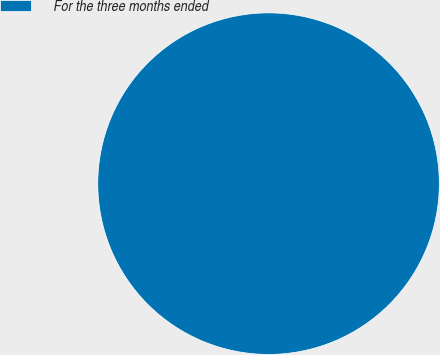Convert chart. <chart><loc_0><loc_0><loc_500><loc_500><pie_chart><fcel>For the three months ended<nl><fcel>100.0%<nl></chart> 